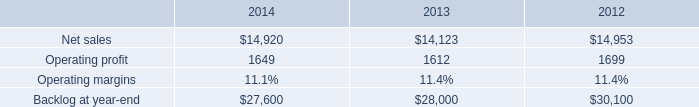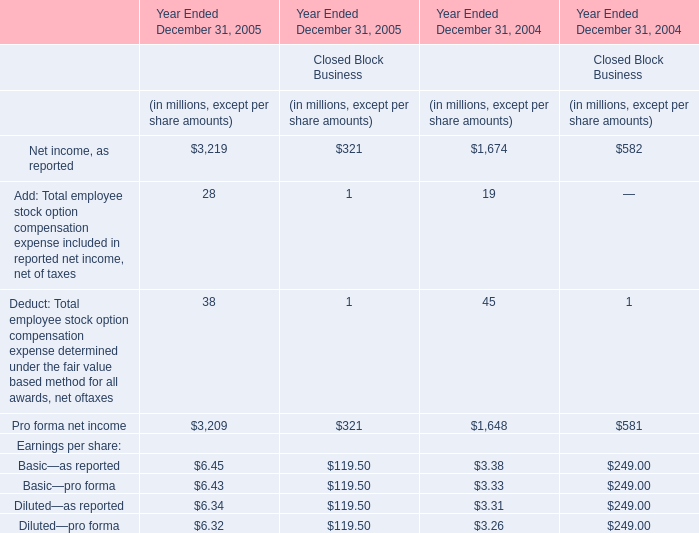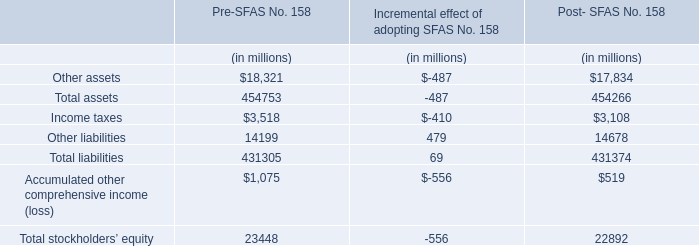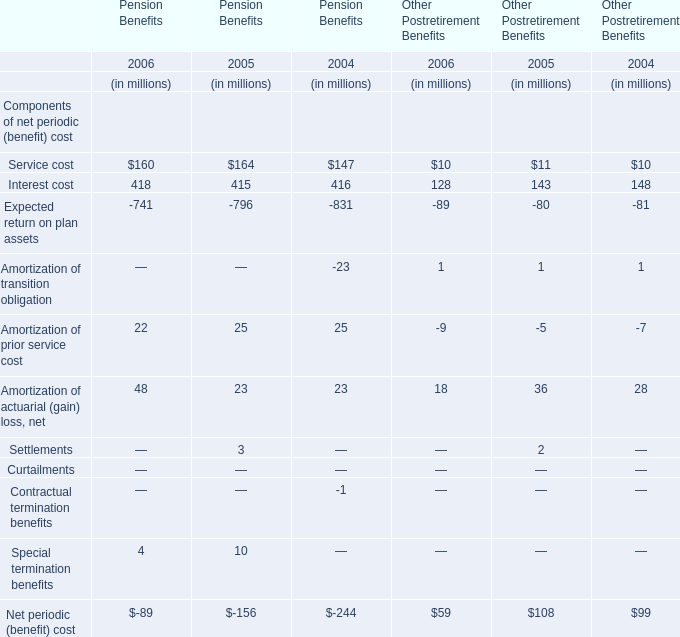What's the sum of all Pre-SFAS No. 158 that are greater than 400000 in Pre-SFAS No. 158? (in million) 
Computations: (454753 + 431305)
Answer: 886058.0. 